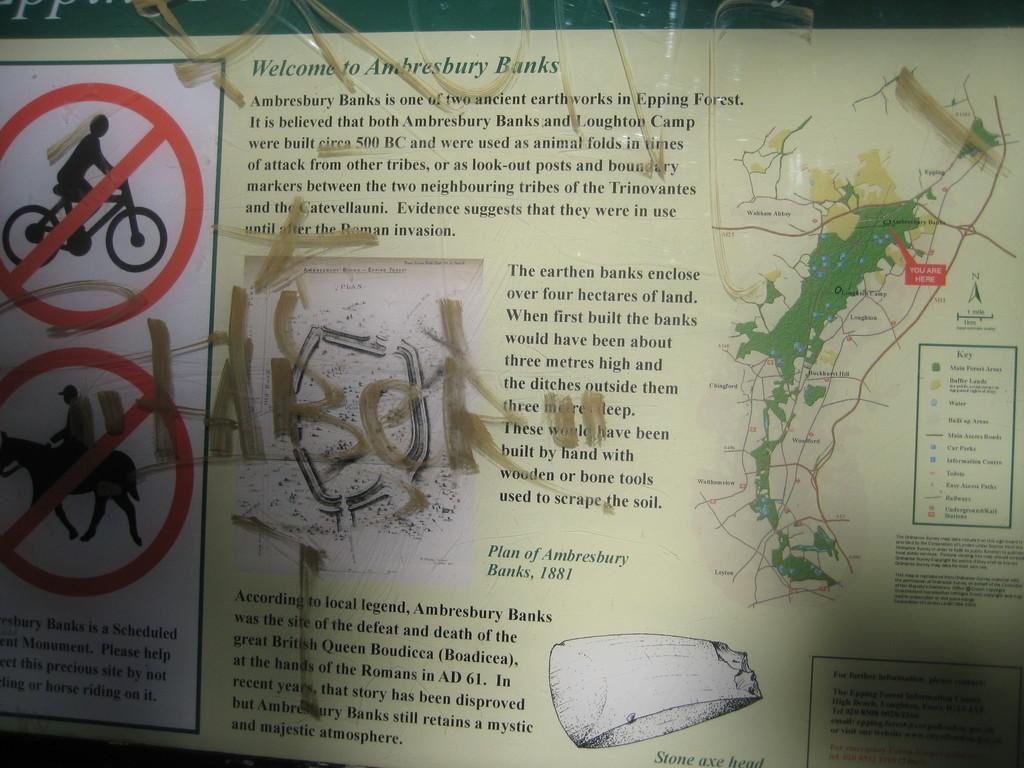<image>
Present a compact description of the photo's key features. graffiti on a paper that says 'welcome to ambresbury banks' 